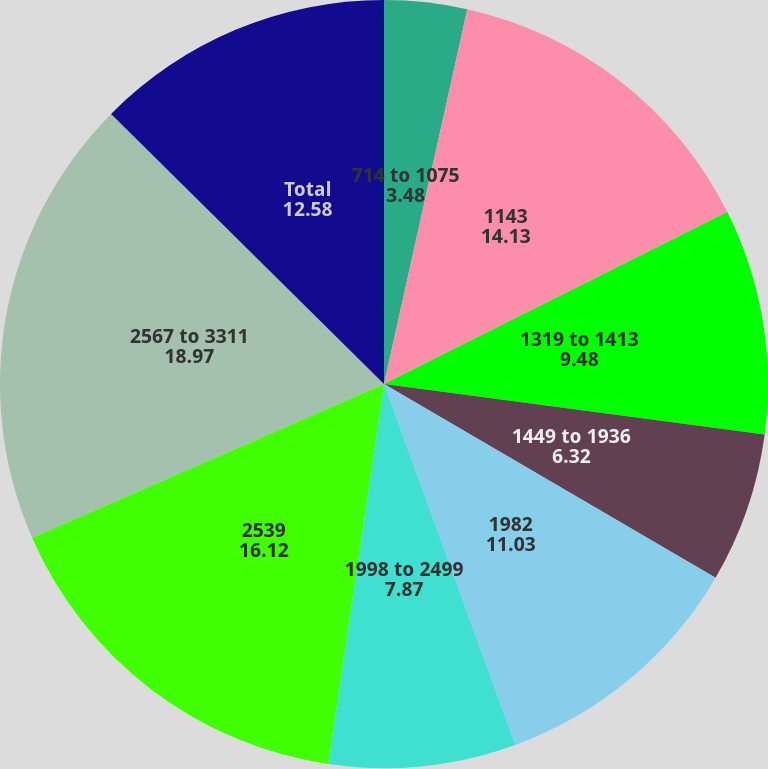Convert chart. <chart><loc_0><loc_0><loc_500><loc_500><pie_chart><fcel>714 to 1075<fcel>1143<fcel>1319 to 1413<fcel>1449 to 1936<fcel>1982<fcel>1998 to 2499<fcel>2539<fcel>2567 to 3311<fcel>Total<nl><fcel>3.48%<fcel>14.13%<fcel>9.48%<fcel>6.32%<fcel>11.03%<fcel>7.87%<fcel>16.12%<fcel>18.97%<fcel>12.58%<nl></chart> 